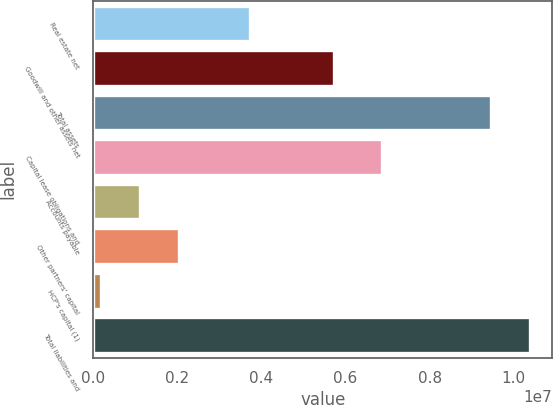Convert chart. <chart><loc_0><loc_0><loc_500><loc_500><bar_chart><fcel>Real estate net<fcel>Goodwill and other assets net<fcel>Total assets<fcel>Capital lease obligations and<fcel>Accounts payable<fcel>Other partners' capital<fcel>HCP's capital (1)<fcel>Total liabilities and<nl><fcel>3.73174e+06<fcel>5.73432e+06<fcel>9.46606e+06<fcel>6.87593e+06<fcel>1.11144e+06<fcel>2.03973e+06<fcel>183146<fcel>1.03943e+07<nl></chart> 